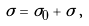Convert formula to latex. <formula><loc_0><loc_0><loc_500><loc_500>\sigma = \sigma _ { 0 } + \tilde { \sigma } \, ,</formula> 